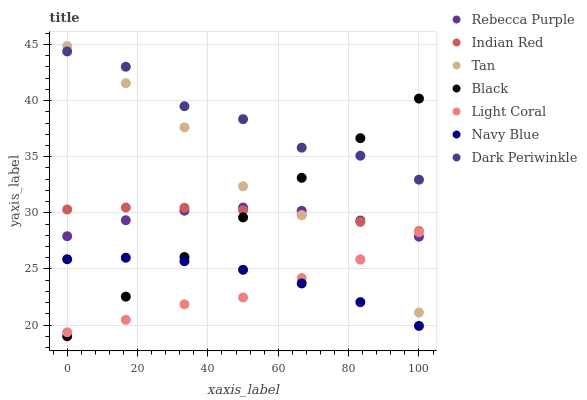Does Light Coral have the minimum area under the curve?
Answer yes or no. Yes. Does Dark Periwinkle have the maximum area under the curve?
Answer yes or no. Yes. Does Black have the minimum area under the curve?
Answer yes or no. No. Does Black have the maximum area under the curve?
Answer yes or no. No. Is Black the smoothest?
Answer yes or no. Yes. Is Dark Periwinkle the roughest?
Answer yes or no. Yes. Is Light Coral the smoothest?
Answer yes or no. No. Is Light Coral the roughest?
Answer yes or no. No. Does Black have the lowest value?
Answer yes or no. Yes. Does Light Coral have the lowest value?
Answer yes or no. No. Does Tan have the highest value?
Answer yes or no. Yes. Does Light Coral have the highest value?
Answer yes or no. No. Is Navy Blue less than Rebecca Purple?
Answer yes or no. Yes. Is Dark Periwinkle greater than Rebecca Purple?
Answer yes or no. Yes. Does Tan intersect Dark Periwinkle?
Answer yes or no. Yes. Is Tan less than Dark Periwinkle?
Answer yes or no. No. Is Tan greater than Dark Periwinkle?
Answer yes or no. No. Does Navy Blue intersect Rebecca Purple?
Answer yes or no. No. 